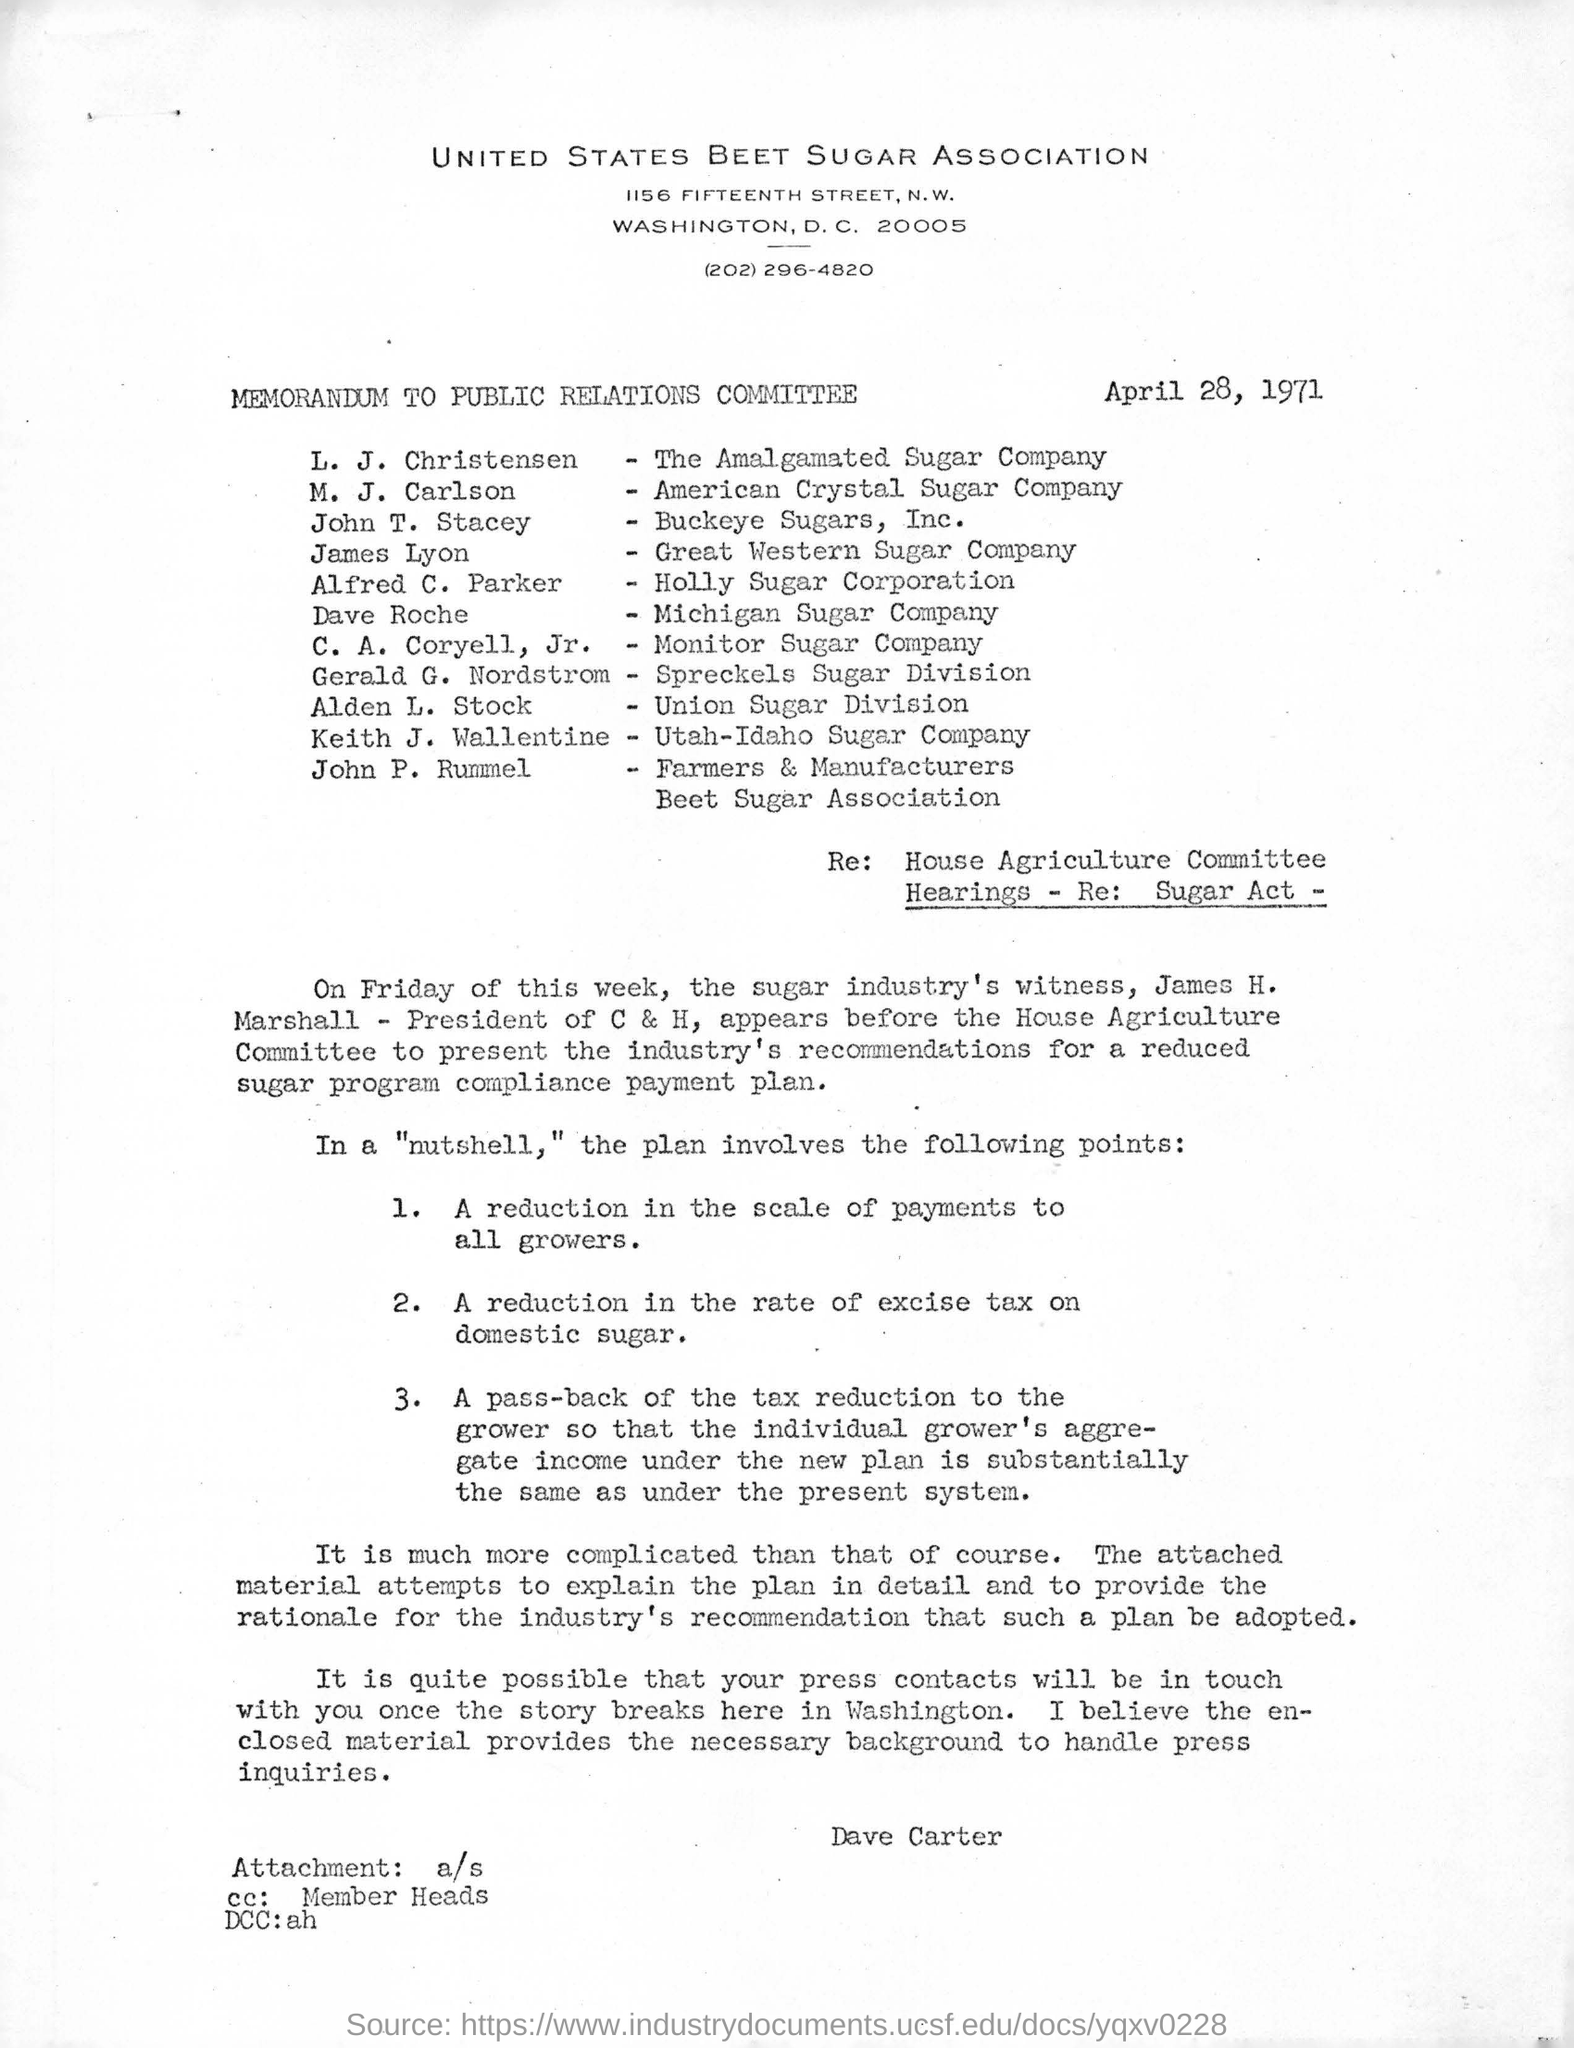Identify some key points in this picture. The date mentioned on the given page is April 28, 1971. James Lyon belongs to the Great Western Sugar Company. L.J. Christensen is a member of the Amalgamated Sugar Company. Dave Roche belongs to the Michigan Sugar Company. M.J. Carlson is a member of the American Crystal Sugar Company. 